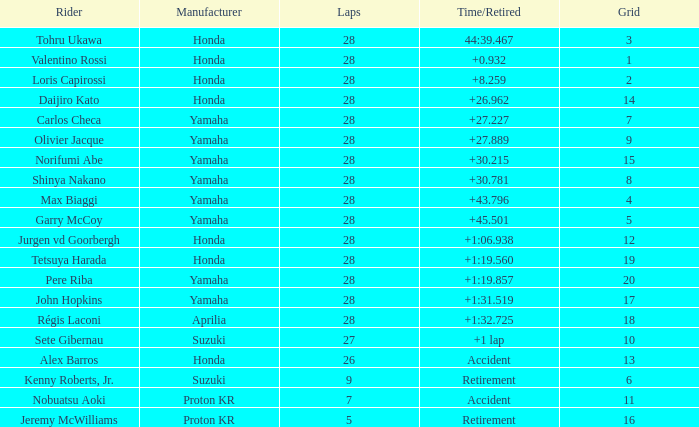How many laps were in grid 4? 28.0. 